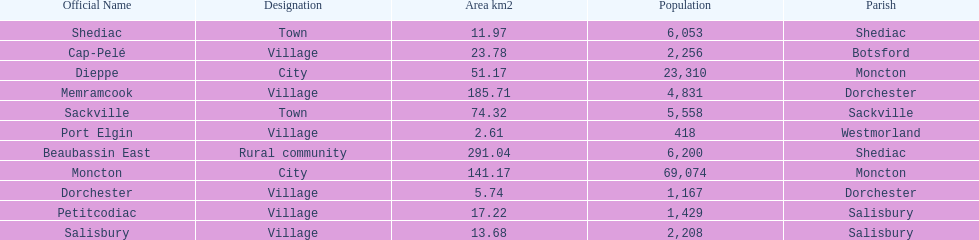City in the same parish of moncton Dieppe. 